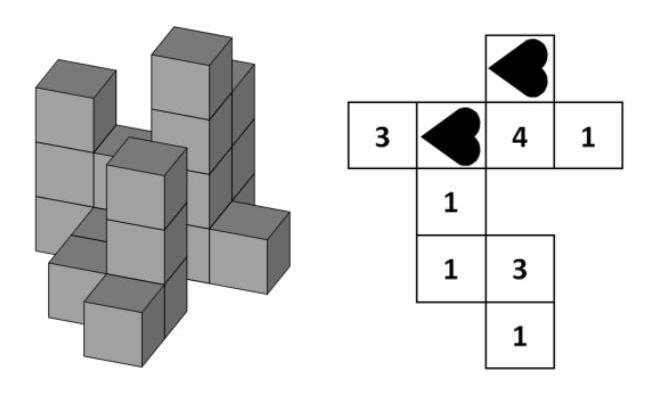Can you explain how the heights of the cubes match the numbers shown in the plan? Each number in the plan represents the height of the towers when viewed from above. For instance, the number '3' indicates a stack of three cubes, '4' means four cubes, and so forth. The plan layout corresponds to the arrangement and heights of the cube towers in the 3D construction. 